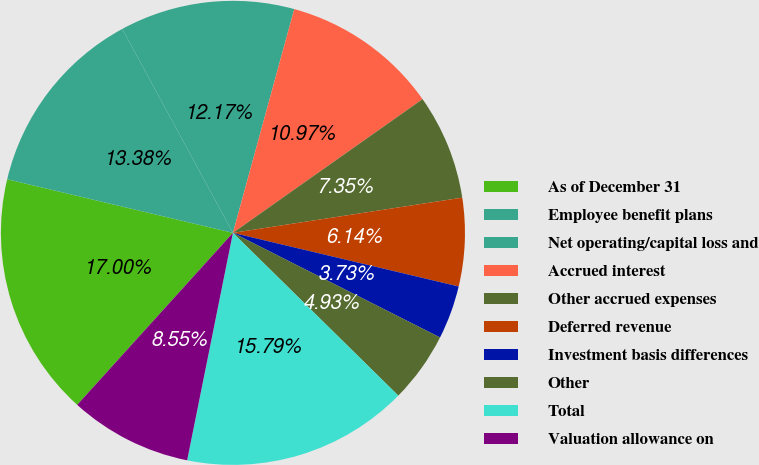<chart> <loc_0><loc_0><loc_500><loc_500><pie_chart><fcel>As of December 31<fcel>Employee benefit plans<fcel>Net operating/capital loss and<fcel>Accrued interest<fcel>Other accrued expenses<fcel>Deferred revenue<fcel>Investment basis differences<fcel>Other<fcel>Total<fcel>Valuation allowance on<nl><fcel>17.0%<fcel>13.38%<fcel>12.17%<fcel>10.97%<fcel>7.35%<fcel>6.14%<fcel>3.73%<fcel>4.93%<fcel>15.79%<fcel>8.55%<nl></chart> 